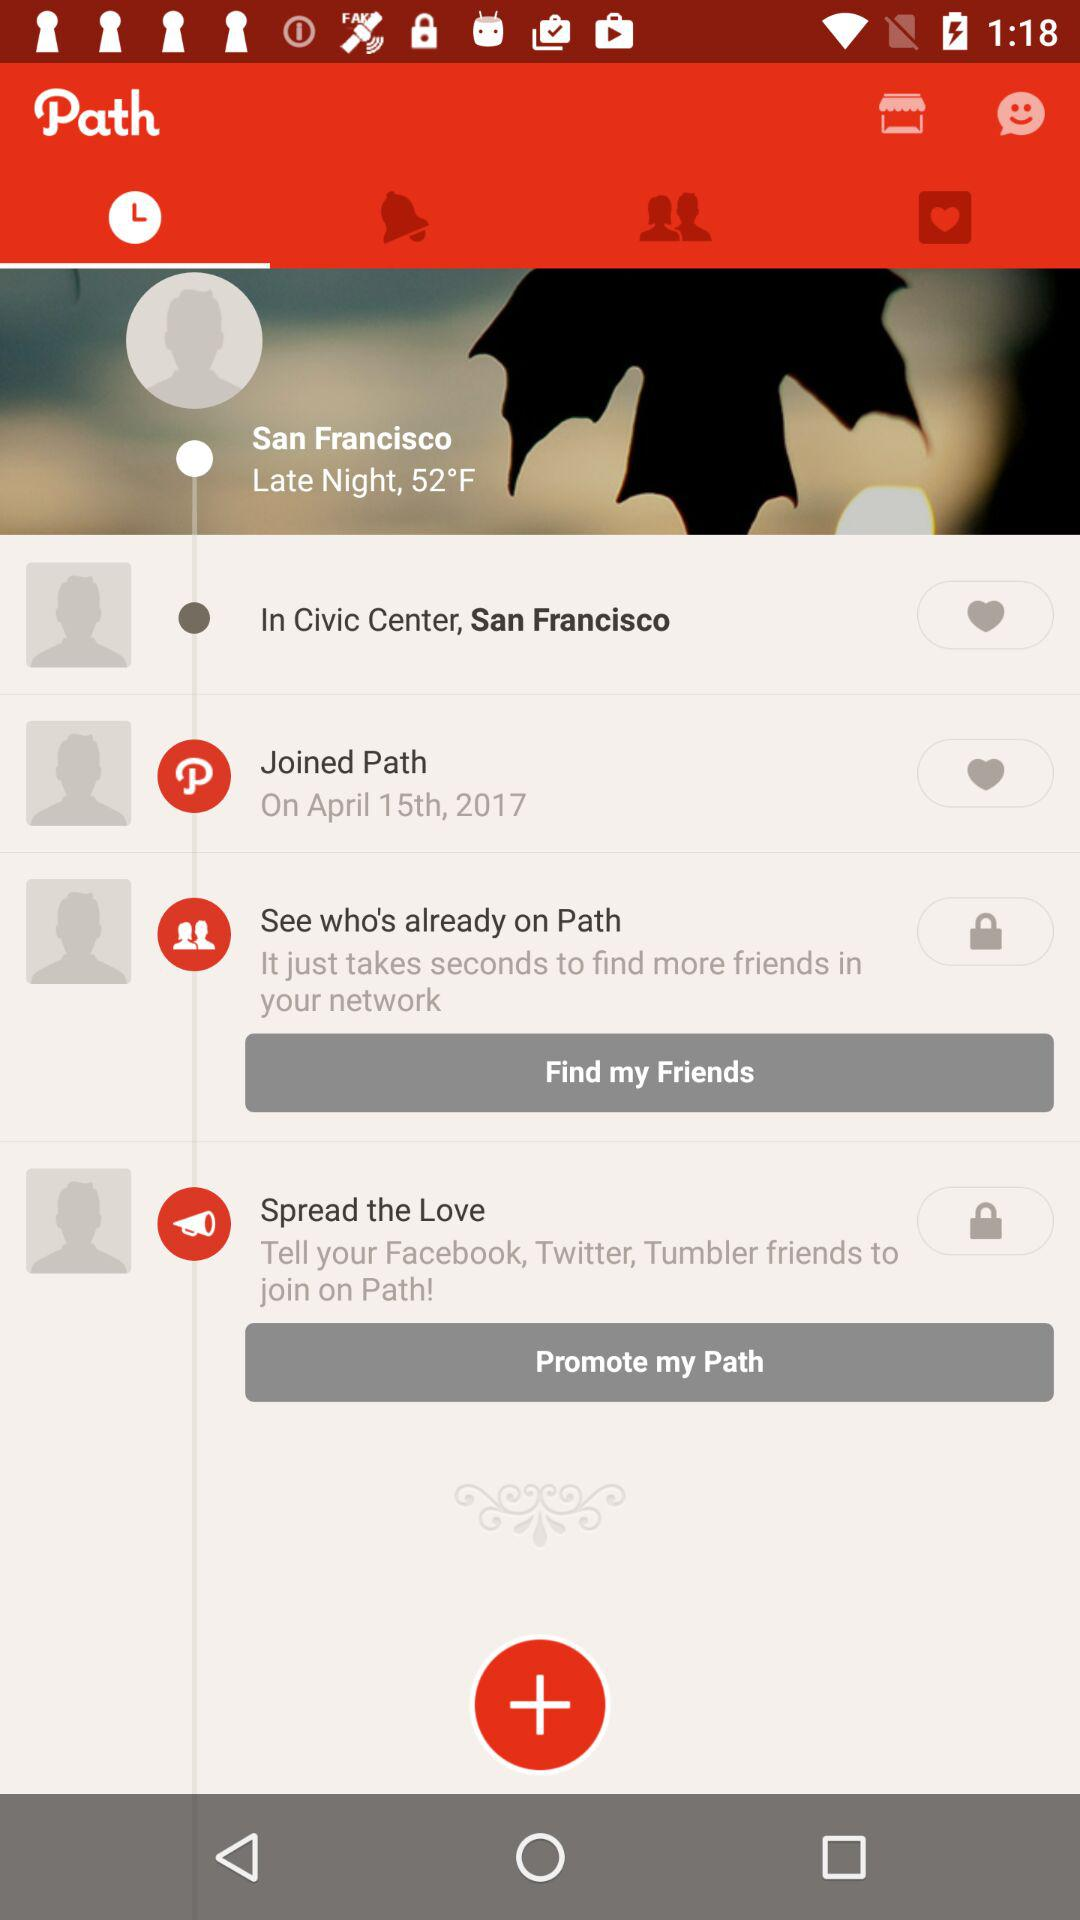What is the temperature in San Francisco? The temperature in San Francisco is 52°F. 